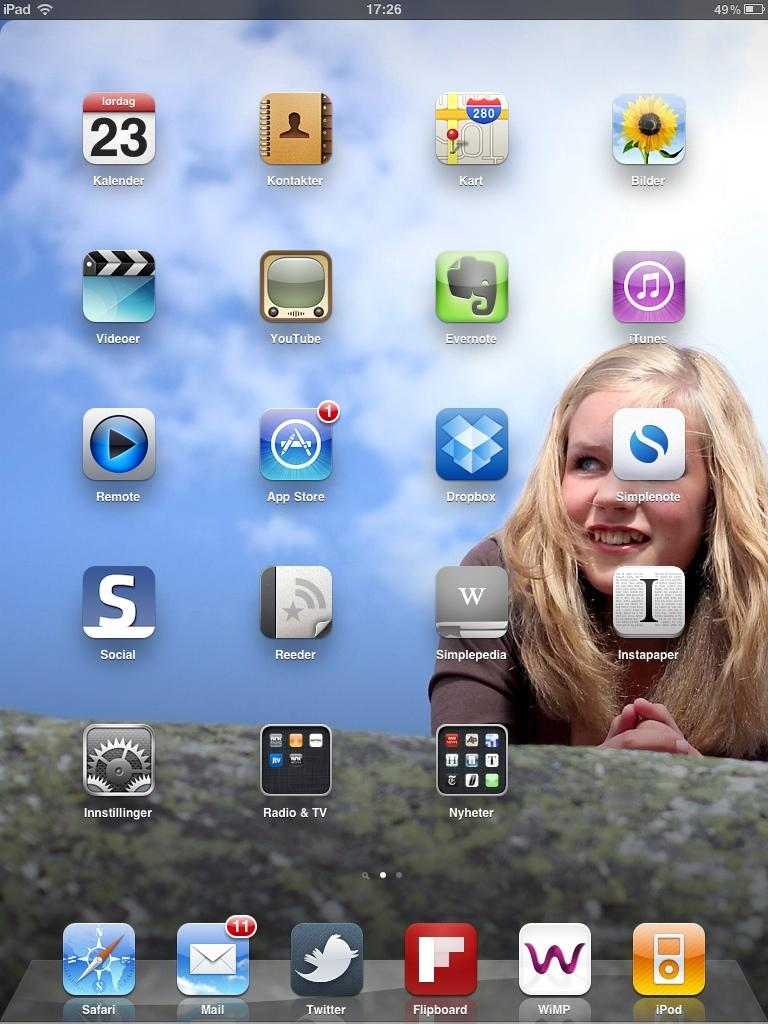<image>
Provide a brief description of the given image. A screenshot of an iPad home screen with the Safari, Mail, Twitter, Flipboard, WIMP and iPod apps at the bottom. 